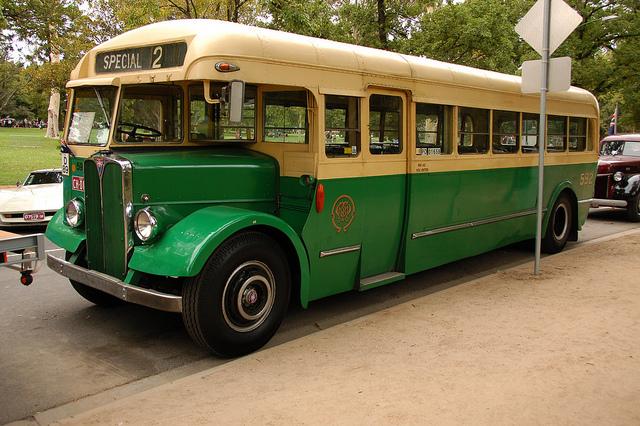What does the sign over the bus's windshield say?
Write a very short answer. Special 2. What is bus marked with on the side?
Give a very brief answer. Logo. What color is the bus?
Keep it brief. Green and yellow. What color is the train?
Answer briefly. Green and yellow. How many windows on the right side of the bus?
Concise answer only. 8. 